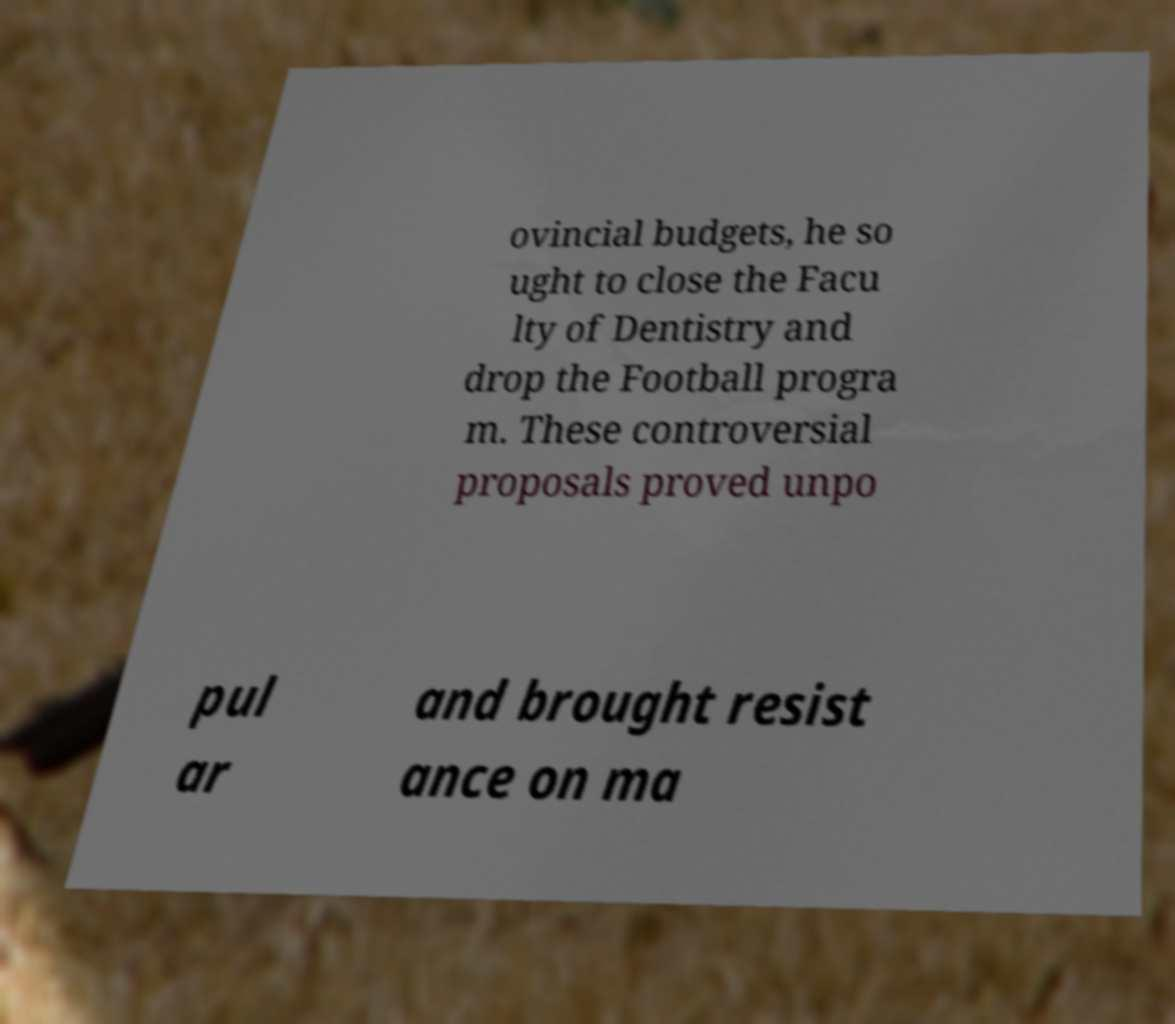What messages or text are displayed in this image? I need them in a readable, typed format. ovincial budgets, he so ught to close the Facu lty of Dentistry and drop the Football progra m. These controversial proposals proved unpo pul ar and brought resist ance on ma 